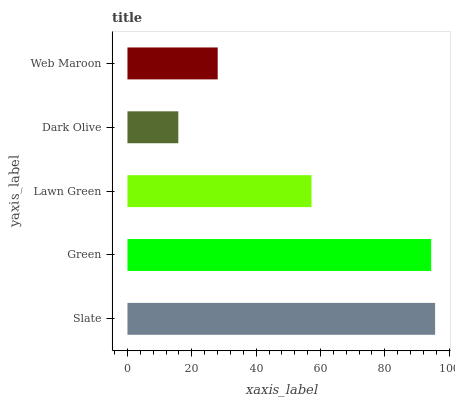Is Dark Olive the minimum?
Answer yes or no. Yes. Is Slate the maximum?
Answer yes or no. Yes. Is Green the minimum?
Answer yes or no. No. Is Green the maximum?
Answer yes or no. No. Is Slate greater than Green?
Answer yes or no. Yes. Is Green less than Slate?
Answer yes or no. Yes. Is Green greater than Slate?
Answer yes or no. No. Is Slate less than Green?
Answer yes or no. No. Is Lawn Green the high median?
Answer yes or no. Yes. Is Lawn Green the low median?
Answer yes or no. Yes. Is Web Maroon the high median?
Answer yes or no. No. Is Green the low median?
Answer yes or no. No. 